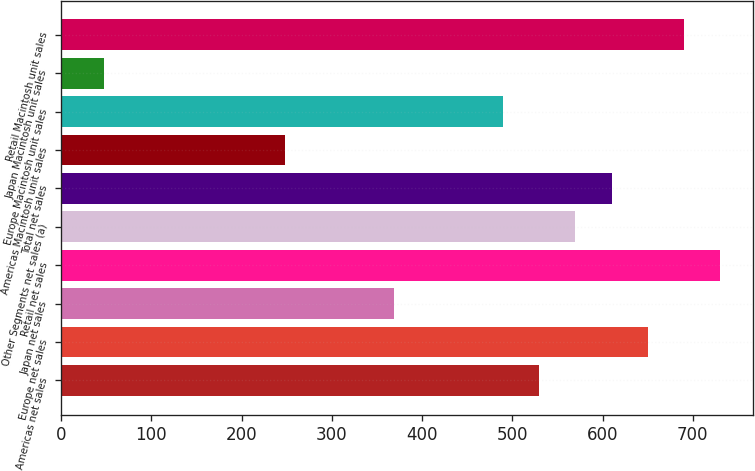Convert chart. <chart><loc_0><loc_0><loc_500><loc_500><bar_chart><fcel>Americas net sales<fcel>Europe net sales<fcel>Japan net sales<fcel>Retail net sales<fcel>Other Segments net sales (a)<fcel>Total net sales<fcel>Americas Macintosh unit sales<fcel>Europe Macintosh unit sales<fcel>Japan Macintosh unit sales<fcel>Retail Macintosh unit sales<nl><fcel>529.6<fcel>650.2<fcel>368.8<fcel>730.6<fcel>569.8<fcel>610<fcel>248.2<fcel>489.4<fcel>47.2<fcel>690.4<nl></chart> 